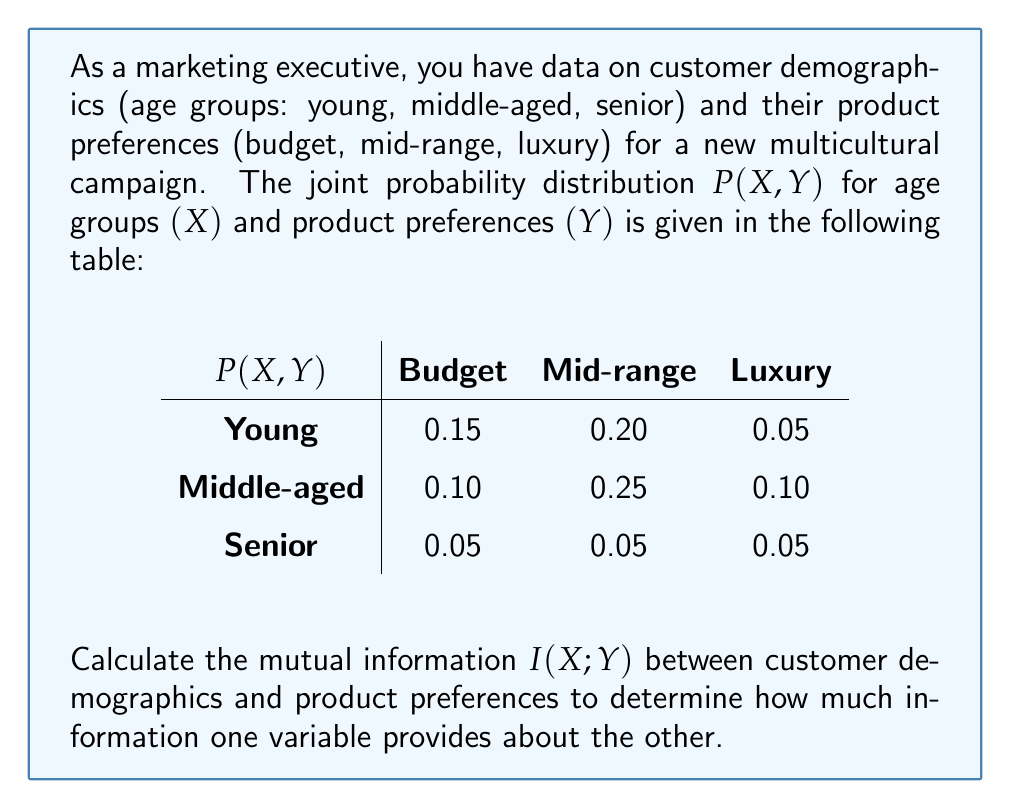Give your solution to this math problem. To calculate the mutual information $I(X;Y)$, we'll follow these steps:

1. Calculate the marginal probabilities $P(X)$ and $P(Y)$.
2. Calculate the mutual information using the formula:

   $$I(X;Y) = \sum_{x \in X} \sum_{y \in Y} P(x,y) \log_2 \frac{P(x,y)}{P(x)P(y)}$$

Step 1: Calculate marginal probabilities

For $P(X)$:
$P(\text{Young}) = 0.15 + 0.20 + 0.05 = 0.40$
$P(\text{Middle-aged}) = 0.10 + 0.25 + 0.10 = 0.45$
$P(\text{Senior}) = 0.05 + 0.05 + 0.05 = 0.15$

For $P(Y)$:
$P(\text{Budget}) = 0.15 + 0.10 + 0.05 = 0.30$
$P(\text{Mid-range}) = 0.20 + 0.25 + 0.05 = 0.50$
$P(\text{Luxury}) = 0.05 + 0.10 + 0.05 = 0.20$

Step 2: Calculate mutual information

We'll calculate each term of the sum separately:

1. $P(\text{Young, Budget}) \log_2 \frac{P(\text{Young, Budget})}{P(\text{Young})P(\text{Budget})} = 0.15 \log_2 \frac{0.15}{0.40 \times 0.30} = 0.0722$
2. $P(\text{Young, Mid-range}) \log_2 \frac{P(\text{Young, Mid-range})}{P(\text{Young})P(\text{Mid-range})} = 0.20 \log_2 \frac{0.20}{0.40 \times 0.50} = 0.0000$
3. $P(\text{Young, Luxury}) \log_2 \frac{P(\text{Young, Luxury})}{P(\text{Young})P(\text{Luxury})} = 0.05 \log_2 \frac{0.05}{0.40 \times 0.20} = -0.0344$
4. $P(\text{Middle-aged, Budget}) \log_2 \frac{P(\text{Middle-aged, Budget})}{P(\text{Middle-aged})P(\text{Budget})} = 0.10 \log_2 \frac{0.10}{0.45 \times 0.30} = -0.0205$
5. $P(\text{Middle-aged, Mid-range}) \log_2 \frac{P(\text{Middle-aged, Mid-range})}{P(\text{Middle-aged})P(\text{Mid-range})} = 0.25 \log_2 \frac{0.25}{0.45 \times 0.50} = 0.0239$
6. $P(\text{Middle-aged, Luxury}) \log_2 \frac{P(\text{Middle-aged, Luxury})}{P(\text{Middle-aged})P(\text{Luxury})} = 0.10 \log_2 \frac{0.10}{0.45 \times 0.20} = 0.0154$
7. $P(\text{Senior, Budget}) \log_2 \frac{P(\text{Senior, Budget})}{P(\text{Senior})P(\text{Budget})} = 0.05 \log_2 \frac{0.05}{0.15 \times 0.30} = 0.0344$
8. $P(\text{Senior, Mid-range}) \log_2 \frac{P(\text{Senior, Mid-range})}{P(\text{Senior})P(\text{Mid-range})} = 0.05 \log_2 \frac{0.05}{0.15 \times 0.50} = -0.0344$
9. $P(\text{Senior, Luxury}) \log_2 \frac{P(\text{Senior, Luxury})}{P(\text{Senior})P(\text{Luxury})} = 0.05 \log_2 \frac{0.05}{0.15 \times 0.20} = 0.0744$

Sum all these terms to get the mutual information:

$I(X;Y) = 0.0722 + 0.0000 - 0.0344 - 0.0205 + 0.0239 + 0.0154 + 0.0344 - 0.0344 + 0.0744 = 0.1310$ bits
Answer: The mutual information $I(X;Y)$ between customer demographics and product preferences is approximately 0.1310 bits. 